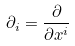Convert formula to latex. <formula><loc_0><loc_0><loc_500><loc_500>\partial _ { i } = \frac { \partial } { \partial x ^ { i } }</formula> 